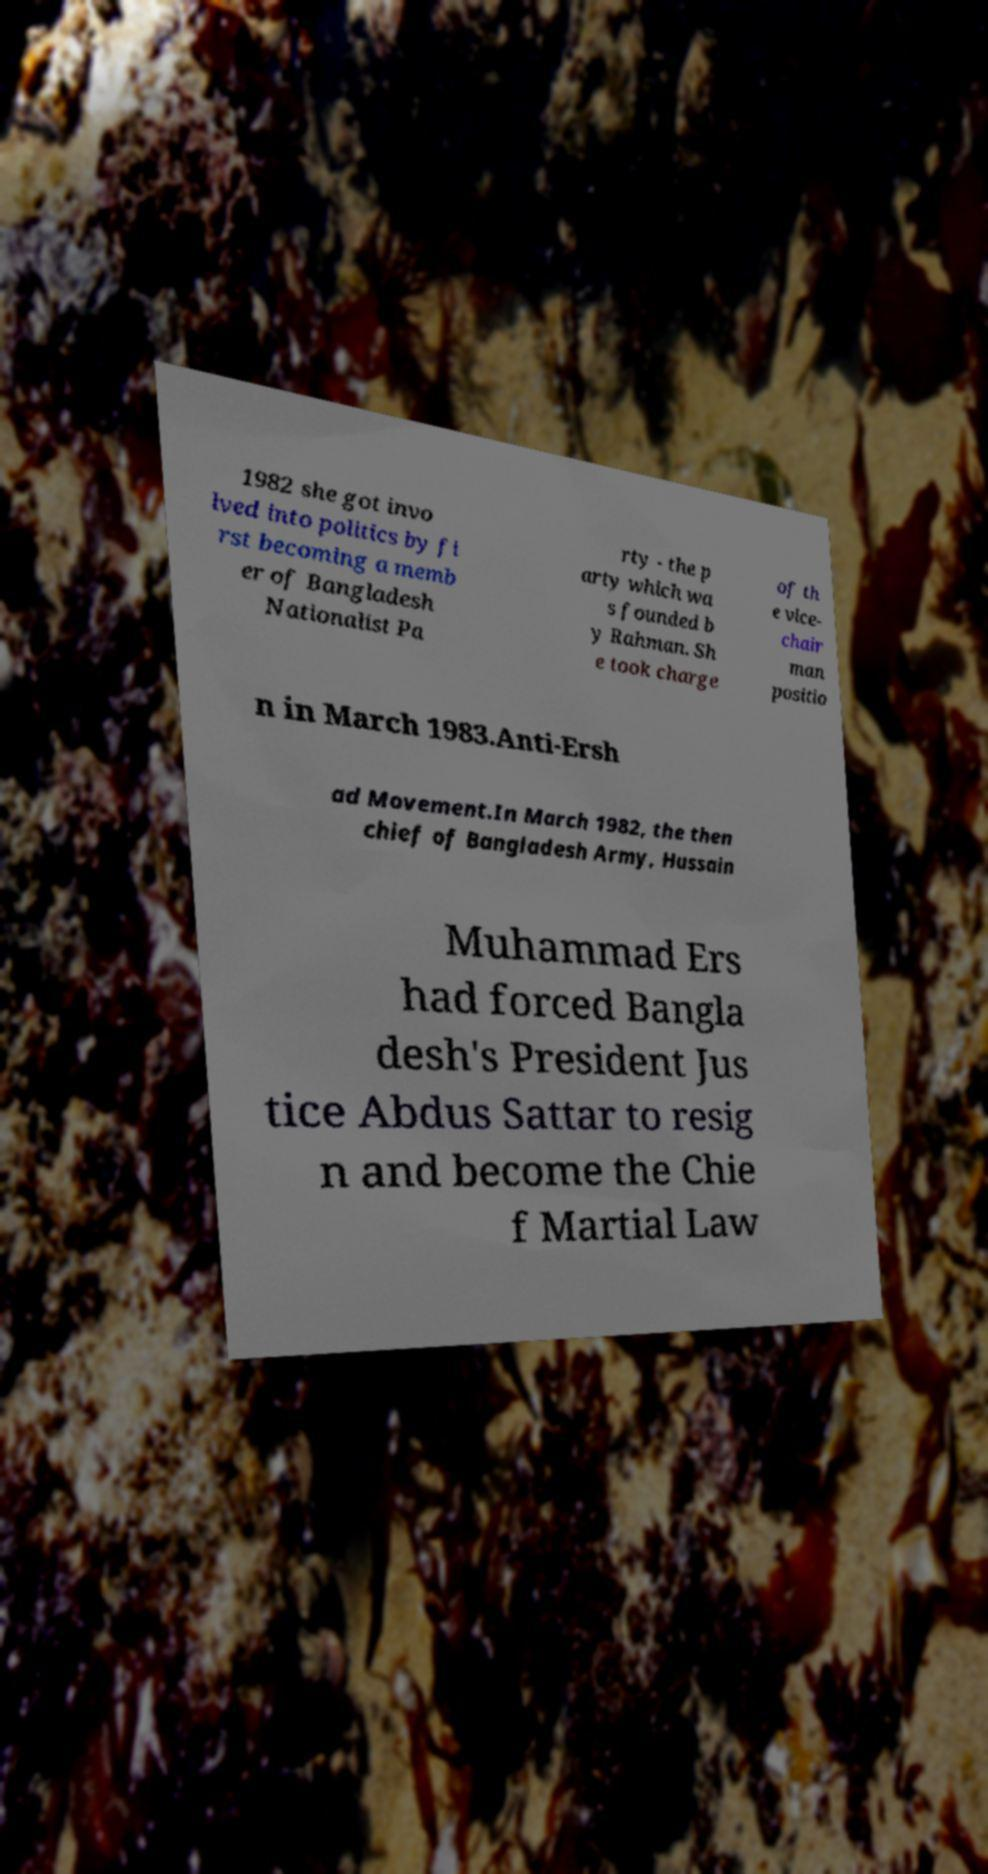I need the written content from this picture converted into text. Can you do that? 1982 she got invo lved into politics by fi rst becoming a memb er of Bangladesh Nationalist Pa rty - the p arty which wa s founded b y Rahman. Sh e took charge of th e vice- chair man positio n in March 1983.Anti-Ersh ad Movement.In March 1982, the then chief of Bangladesh Army, Hussain Muhammad Ers had forced Bangla desh's President Jus tice Abdus Sattar to resig n and become the Chie f Martial Law 